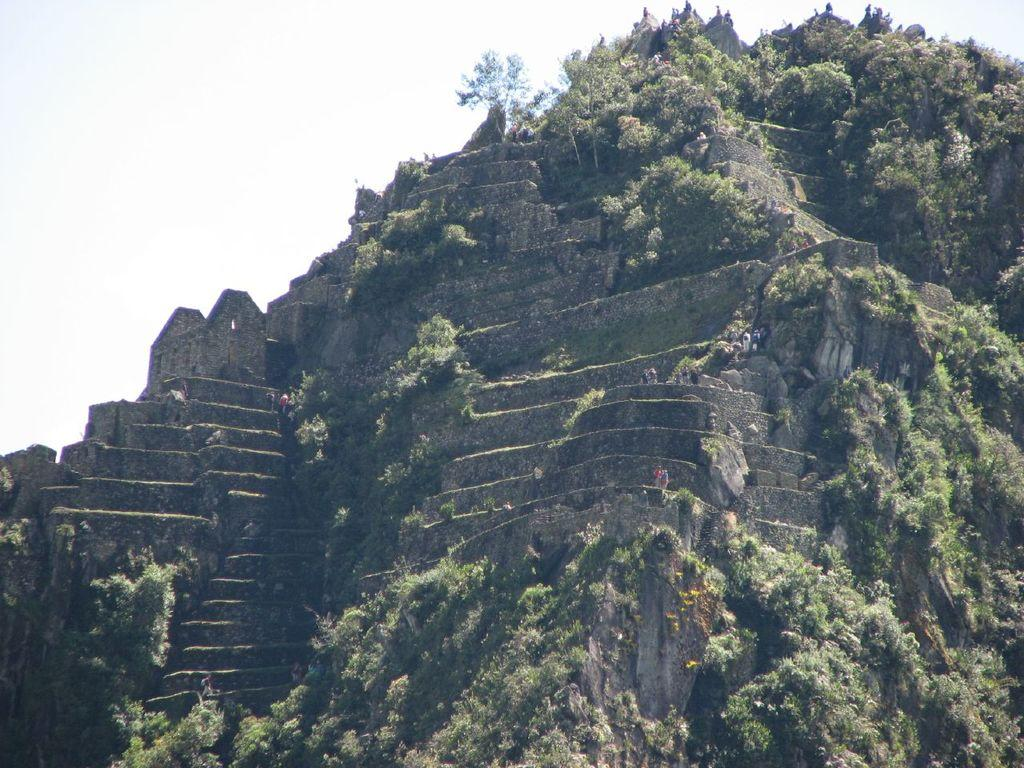What type of natural formation is visible in the image? There is a mountain in the image. What type of vegetation can be seen in the image? There are trees in the image. Are there any human figures in the image? Yes, there are people in the image. What is visible in the background of the image? The sky is visible in the background of the image. What type of cloth is being used to support the mountain in the image? There is no cloth present in the image, and the mountain is not being supported by any external means. Can you see a robin perched on one of the trees in the image? There is no mention of a robin in the image, so we cannot confirm its presence. 